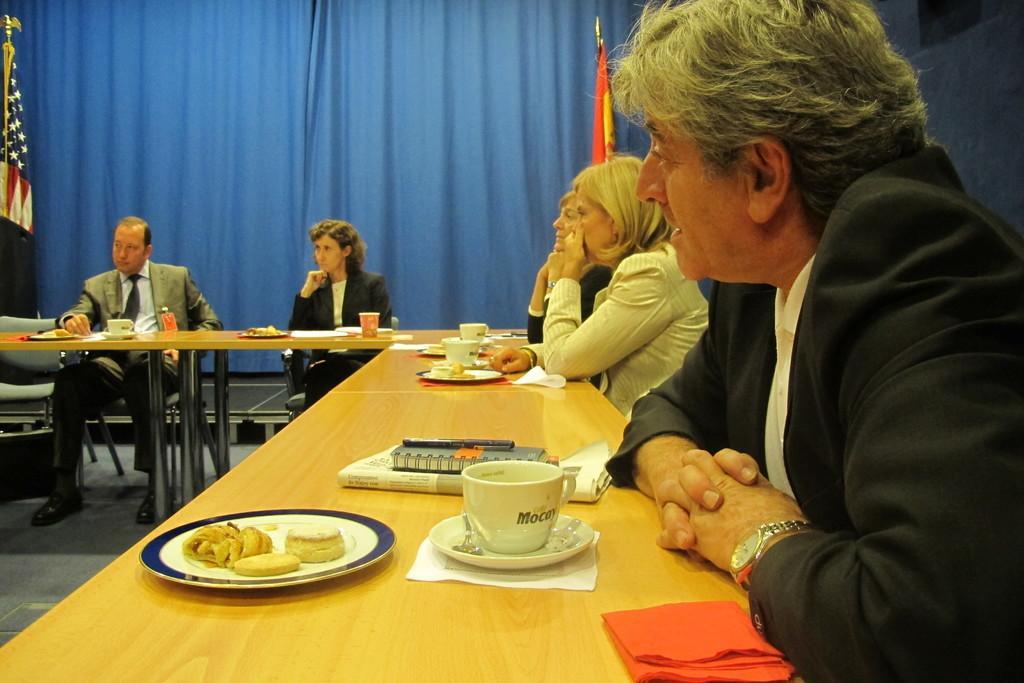Please provide a concise description of this image. inside the room there are many people sitting on the chair and two table are present on the table and many things are present on the table like book,paper,plates and biscuits are also present on the chair 